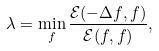<formula> <loc_0><loc_0><loc_500><loc_500>\lambda = \min _ { f } \frac { \mathcal { E } ( - \Delta f , f ) } { \mathcal { E } ( f , f ) } ,</formula> 